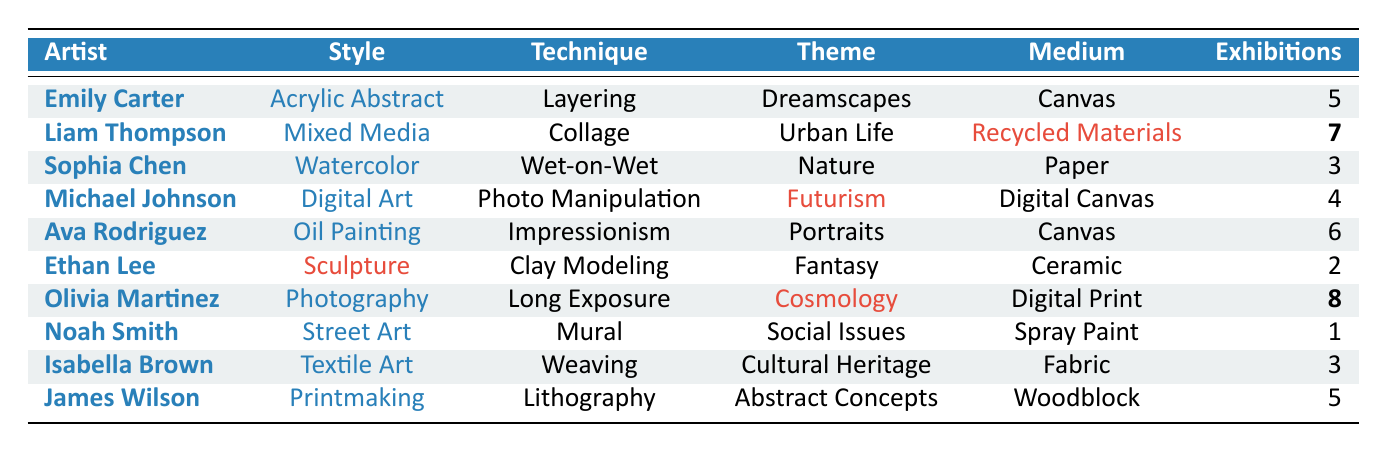What is the most common medium used by the artists? By examining the table, we look at the "Medium" column and see three artists use "Canvas" (Emily Carter, Ava Rodriguez). Other mediums have fewer occurrences. Thus, "Canvas" is the most common medium.
Answer: Canvas How many artists exhibited their work at least 5 times? By checking the "Exhibitions" column, we count Emily Carter (5), Liam Thompson (7), Ava Rodriguez (6), Olivia Martinez (8), and James Wilson (5). That totals to 5 artists who exhibited at least 5 times.
Answer: 5 Which artist has the highest exhibition count? We review the "Exhibitions" column to find that Olivia Martinez has the highest count at 8 exhibitions.
Answer: Olivia Martinez Is there an artist who uses "Sculpture" as their style? Checking the "Style" column, we see that Ethan Lee represents "Sculpture." Thus, yes, there is such an artist.
Answer: Yes What is the difference in exhibition counts between the artist with the most and the artist with the least exhibitions? The artist with the most exhibitions is Olivia Martinez (8), and the one with the least is Noah Smith (1). The difference in their counts is 8 - 1 = 7.
Answer: 7 What themes are represented by artists who use a technique involving "Exposure"? Looking at the "Technique" column, we see that only Olivia Martinez uses "Long Exposure," and her theme is "Cosmology." Thus, the theme represented is "Cosmology."
Answer: Cosmology Which style has the most exhibitors with 3 exhibitions? In the "Exhibitions" column, we note that both Sophia Chen and Isabella Brown have 3 exhibitions, and their respective styles are "Watercolor" and "Textile Art." There are 2 styles with this exhibition count.
Answer: 2 styles How many distinct techniques were used in the exhibition overall? By reviewing the "Technique" column, we identify unique techniques: Layering, Collage, Wet-on-Wet, Photo Manipulation, Impressionism, Clay Modeling, Long Exposure, Mural, Weaving, and Lithography. This totals to 10 distinct techniques.
Answer: 10 Which artist's work represents the theme of "Fantasy"? Checking the "Theme" column, we find that the work of Ethan Lee represents the theme of "Fantasy."
Answer: Ethan Lee What is the average number of exhibitions per artist? There are 10 artists in total. We calculate the sum of their exhibitions: (5 + 7 + 3 + 4 + 6 + 2 + 8 + 1 + 3 + 5) = 44. Dividing by the number of artists gives: 44 / 10 = 4.4.
Answer: 4.4 